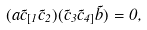<formula> <loc_0><loc_0><loc_500><loc_500>( a \vec { c } _ { [ 1 } \vec { c } _ { 2 } ) ( \vec { c } _ { 3 } \vec { c } _ { 4 ] } \vec { b } ) = 0 ,</formula> 